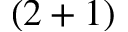Convert formula to latex. <formula><loc_0><loc_0><loc_500><loc_500>( 2 + 1 )</formula> 